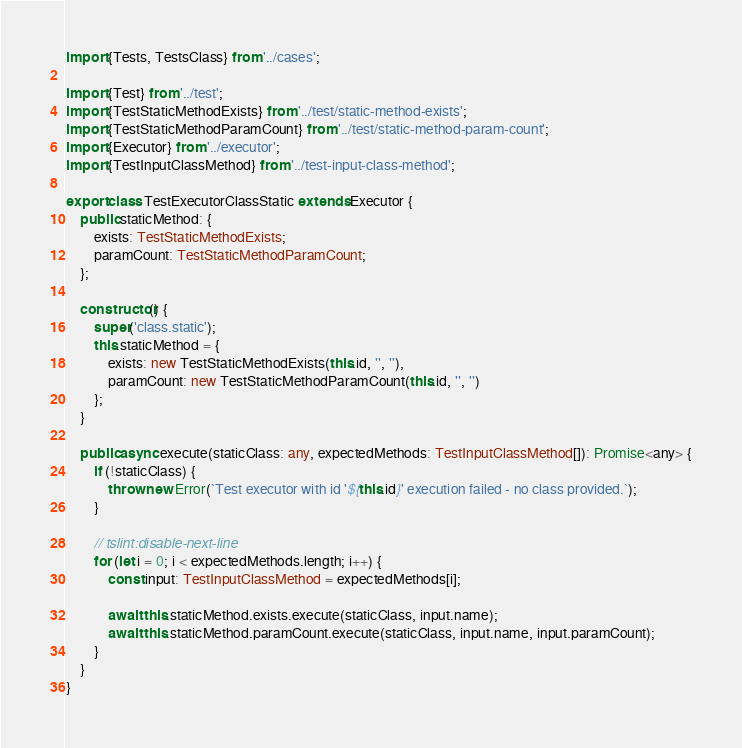Convert code to text. <code><loc_0><loc_0><loc_500><loc_500><_TypeScript_>import {Tests, TestsClass} from '../cases';

import {Test} from '../test';
import {TestStaticMethodExists} from '../test/static-method-exists';
import {TestStaticMethodParamCount} from '../test/static-method-param-count';
import {Executor} from '../executor';
import {TestInputClassMethod} from '../test-input-class-method';

export class TestExecutorClassStatic extends Executor {
	public staticMethod: {
		exists: TestStaticMethodExists;
		paramCount: TestStaticMethodParamCount;
	};

	constructor() {
		super('class.static');
		this.staticMethod = {
			exists: new TestStaticMethodExists(this.id, '', ''),
			paramCount: new TestStaticMethodParamCount(this.id, '', '')
		};
	}

	public async execute(staticClass: any, expectedMethods: TestInputClassMethod[]): Promise<any> {
		if (!staticClass) {
			throw new Error(`Test executor with id '${this.id}' execution failed - no class provided.`);
		}

		// tslint:disable-next-line
		for (let i = 0; i < expectedMethods.length; i++) {
			const input: TestInputClassMethod = expectedMethods[i];

			await this.staticMethod.exists.execute(staticClass, input.name);
			await this.staticMethod.paramCount.execute(staticClass, input.name, input.paramCount);
		}
	}
}
</code> 